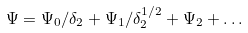Convert formula to latex. <formula><loc_0><loc_0><loc_500><loc_500>\Psi = \Psi _ { 0 } / \delta _ { 2 } + \Psi _ { 1 } / \delta _ { 2 } ^ { 1 / 2 } + \Psi _ { 2 } + \dots</formula> 